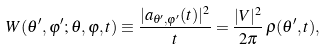<formula> <loc_0><loc_0><loc_500><loc_500>W ( \theta ^ { \prime } , \varphi ^ { \prime } & ; \theta , \varphi , t ) \equiv \frac { | a _ { \theta ^ { \prime } , \varphi ^ { \prime } } ( t ) | ^ { 2 } } { t } = \frac { | V | ^ { 2 } } { 2 \pi } \, \rho ( \theta ^ { \prime } , t ) ,</formula> 